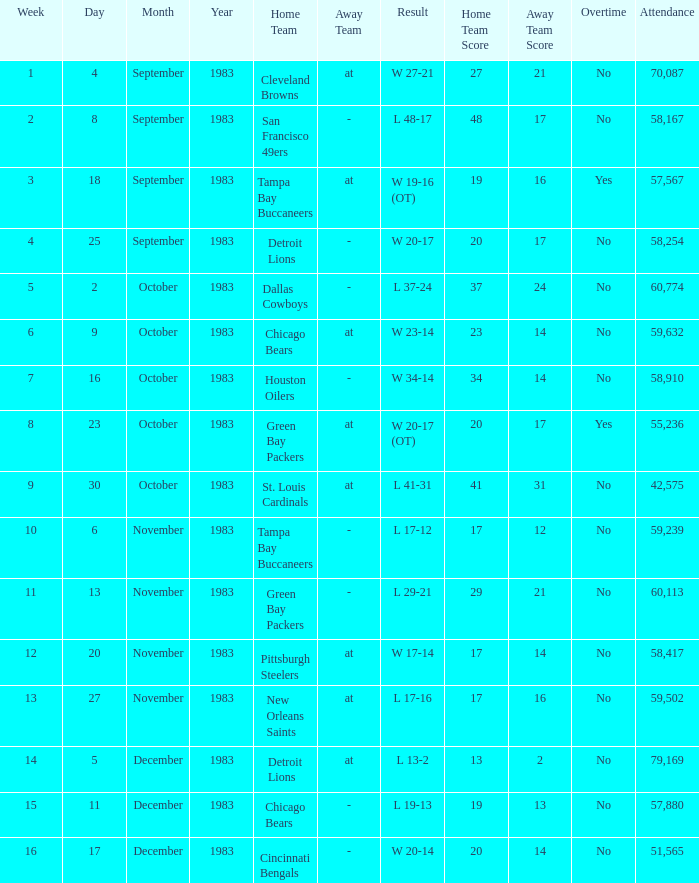Can you parse all the data within this table? {'header': ['Week', 'Day', 'Month', 'Year', 'Home Team', 'Away Team', 'Result', 'Home Team Score', 'Away Team Score', 'Overtime', 'Attendance'], 'rows': [['1', '4', 'September', '1983', 'Cleveland Browns', 'at', 'W 27-21', '27', '21', 'No', '70,087'], ['2', '8', 'September', '1983', 'San Francisco 49ers', '-', 'L 48-17', '48', '17', 'No', '58,167'], ['3', '18', 'September', '1983', 'Tampa Bay Buccaneers', 'at', 'W 19-16 (OT)', '19', '16', 'Yes', '57,567'], ['4', '25', 'September', '1983', 'Detroit Lions', '-', 'W 20-17', '20', '17', 'No', '58,254'], ['5', '2', 'October', '1983', 'Dallas Cowboys', '-', 'L 37-24', '37', '24', 'No', '60,774'], ['6', '9', 'October', '1983', 'Chicago Bears', 'at', 'W 23-14', '23', '14', 'No', '59,632'], ['7', '16', 'October', '1983', 'Houston Oilers', '-', 'W 34-14', '34', '14', 'No', '58,910'], ['8', '23', 'October', '1983', 'Green Bay Packers', 'at', 'W 20-17 (OT)', '20', '17', 'Yes', '55,236'], ['9', '30', 'October', '1983', 'St. Louis Cardinals', 'at', 'L 41-31', '41', '31', 'No', '42,575'], ['10', '6', 'November', '1983', 'Tampa Bay Buccaneers', '-', 'L 17-12', '17', '12', 'No', '59,239'], ['11', '13', 'November', '1983', 'Green Bay Packers', '-', 'L 29-21', '29', '21', 'No', '60,113'], ['12', '20', 'November', '1983', 'Pittsburgh Steelers', 'at', 'W 17-14', '17', '14', 'No', '58,417'], ['13', '27', 'November', '1983', 'New Orleans Saints', 'at', 'L 17-16', '17', '16', 'No', '59,502'], ['14', '5', 'December', '1983', 'Detroit Lions', 'at', 'L 13-2', '13', '2', 'No', '79,169'], ['15', '11', 'December', '1983', 'Chicago Bears', '-', 'L 19-13', '19', '13', 'No', '57,880'], ['16', '17', 'December', '1983', 'Cincinnati Bengals', '-', 'W 20-14', '20', '14', 'No', '51,565']]} What happened on November 20, 1983 before week 15? W 17-14. 